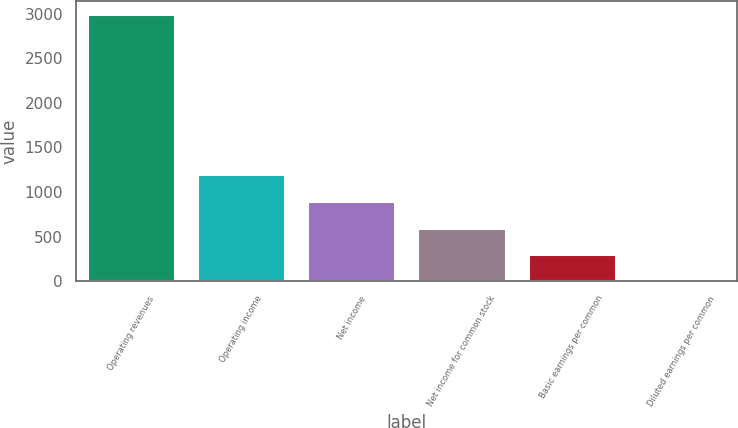Convert chart. <chart><loc_0><loc_0><loc_500><loc_500><bar_chart><fcel>Operating revenues<fcel>Operating income<fcel>Net income<fcel>Net income for common stock<fcel>Basic earnings per common<fcel>Diluted earnings per common<nl><fcel>2993<fcel>1197.52<fcel>898.28<fcel>599.04<fcel>299.8<fcel>0.56<nl></chart> 